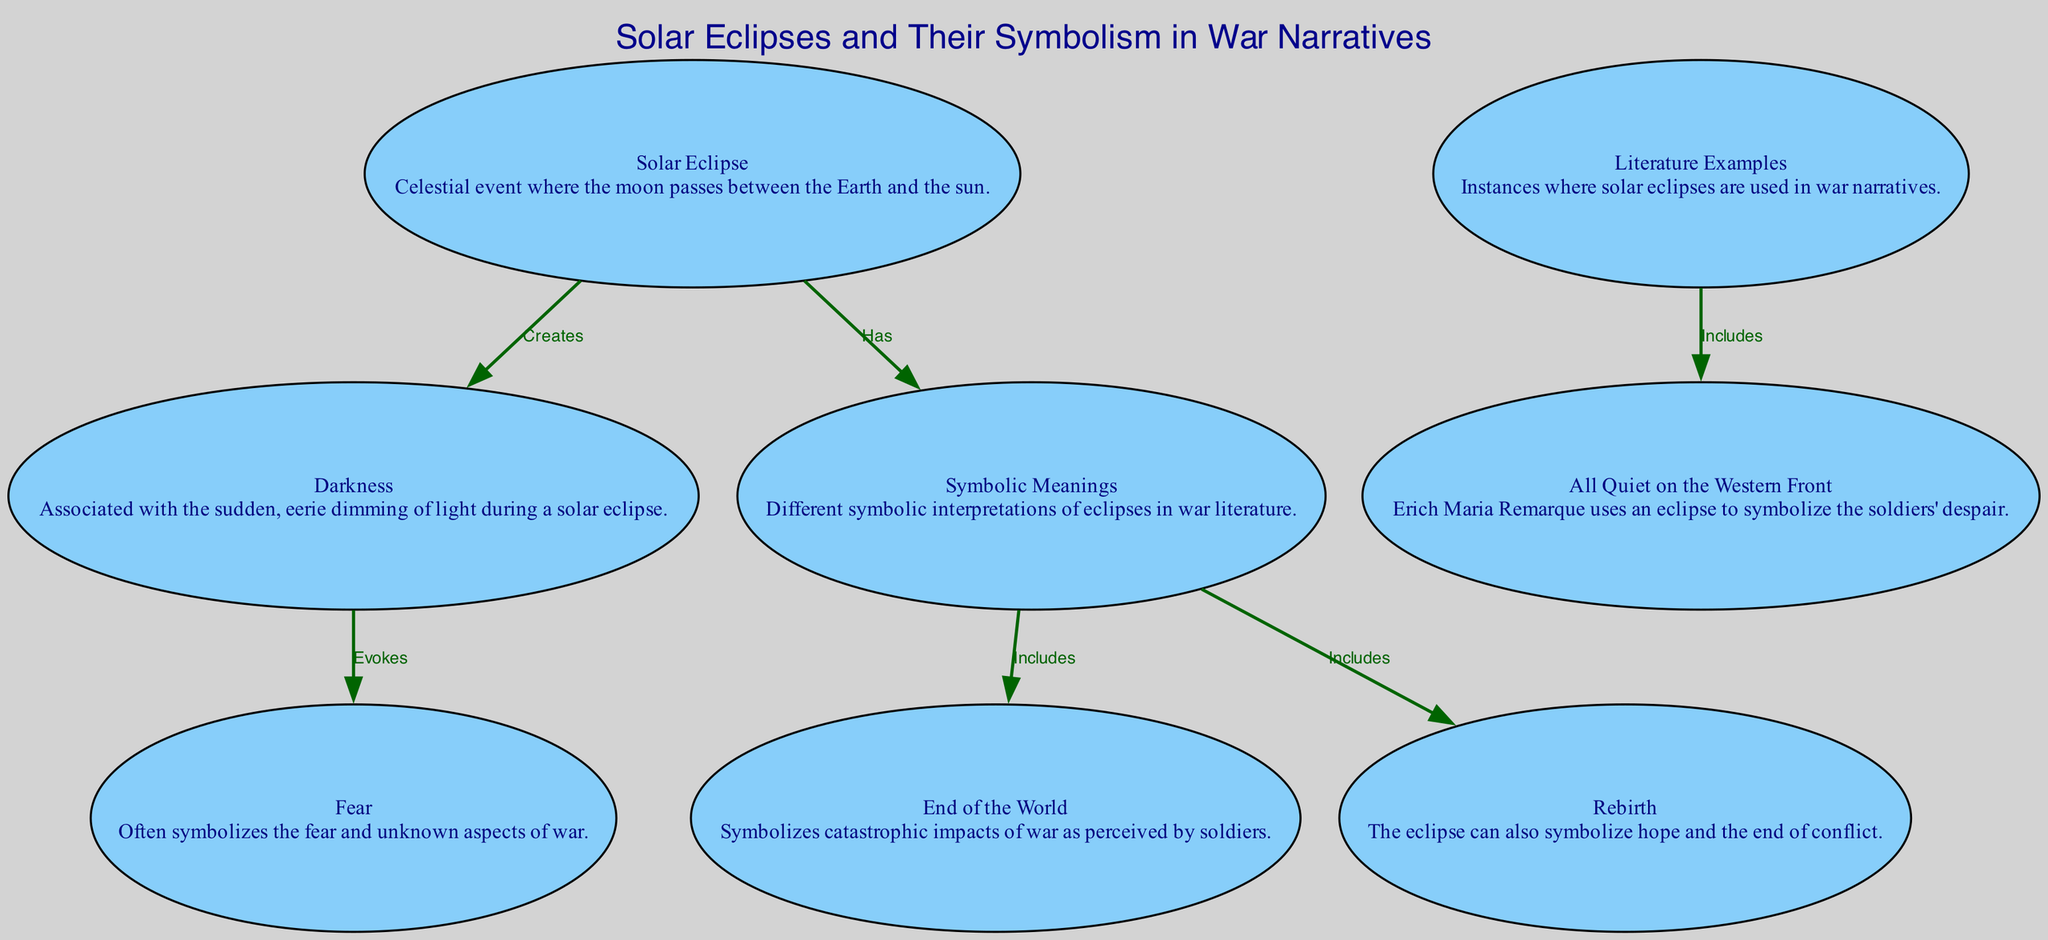What does a solar eclipse create? The diagram indicates that a solar eclipse creates "Darkness". It shows an edge from the "solar_eclipse" node to the "darkness" node labeled "Creates".
Answer: Darkness How many literature examples are mentioned? The diagram includes one example under the "literature_examples" node, which is specifically "All Quiet on the Western Front".
Answer: One What symbol is associated with the fear in war? According to the diagram, "Fear" is directly associated with the "Darkness" created by the solar eclipse. Through the flow indicated by the edge from "darkness" to "fear", we can see this relationship.
Answer: Fear What are the two symbolic meanings included related to war? The diagram indicates that the "symbolic_meanings" node includes two aspects: "End of the World" and "Rebirth". This is depicted through edges leading from "symbolic_meanings" to both of these nodes.
Answer: End of the World, Rebirth Which war narrative uses an eclipse to symbolize despair? The diagram clearly shows that "All Quiet on the Western Front" is the literature example included that uses an eclipse to symbolize the despair of soldiers. This is highlighted by the edge connecting "literature_examples" to "all_quiet_on_the_western_front".
Answer: All Quiet on the Western Front What emotion does darkness during a solar eclipse evoke? The diagram states that the "Darkness" created by a solar eclipse evokes "Fear". This is indicated by the direct edge flowing from "darkness" to "fear".
Answer: Fear What does the symbolism of rebirth represent in this context? In the context of the diagram, "Rebirth" symbolizes hope and the end of conflict as interpreted from the symbolic meanings derived from the eclipse. This is evident from the edge that connects "symbolic_meanings" to "rebirth".
Answer: Hope and the end of conflict 